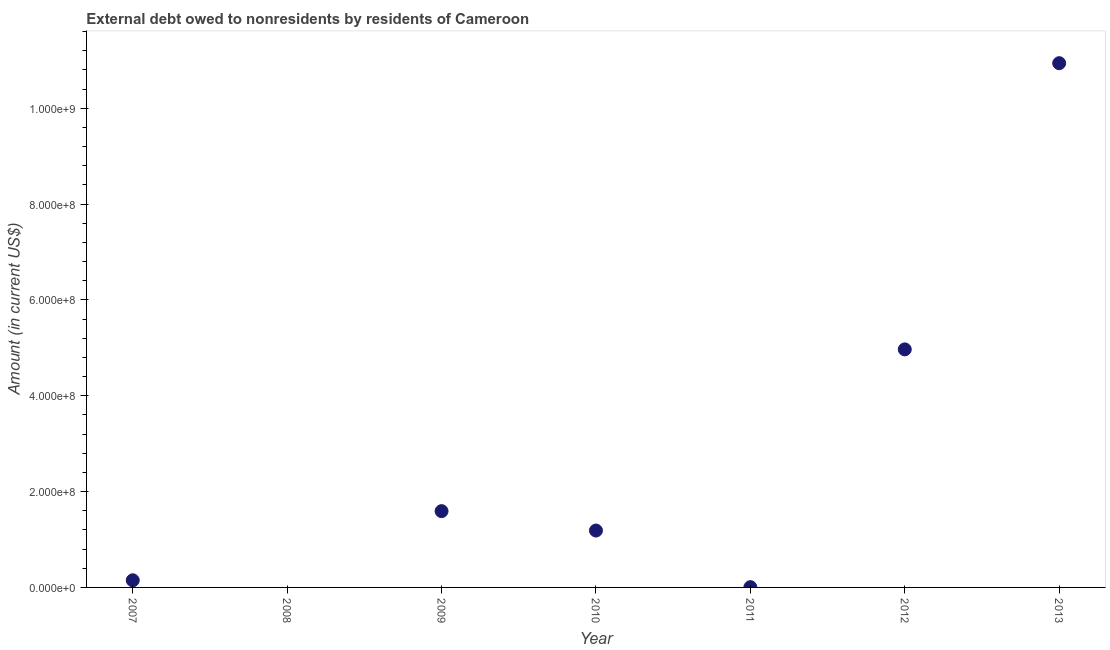What is the debt in 2009?
Offer a terse response. 1.59e+08. Across all years, what is the maximum debt?
Keep it short and to the point. 1.09e+09. Across all years, what is the minimum debt?
Keep it short and to the point. 0. In which year was the debt maximum?
Provide a succinct answer. 2013. What is the sum of the debt?
Make the answer very short. 1.88e+09. What is the difference between the debt in 2007 and 2011?
Give a very brief answer. 1.44e+07. What is the average debt per year?
Your answer should be very brief. 2.69e+08. What is the median debt?
Keep it short and to the point. 1.19e+08. What is the ratio of the debt in 2011 to that in 2013?
Provide a succinct answer. 0. What is the difference between the highest and the second highest debt?
Your response must be concise. 5.97e+08. What is the difference between the highest and the lowest debt?
Your answer should be compact. 1.09e+09. What is the difference between two consecutive major ticks on the Y-axis?
Make the answer very short. 2.00e+08. Does the graph contain grids?
Your answer should be compact. No. What is the title of the graph?
Your answer should be very brief. External debt owed to nonresidents by residents of Cameroon. What is the label or title of the Y-axis?
Ensure brevity in your answer.  Amount (in current US$). What is the Amount (in current US$) in 2007?
Offer a very short reply. 1.49e+07. What is the Amount (in current US$) in 2008?
Keep it short and to the point. 0. What is the Amount (in current US$) in 2009?
Provide a short and direct response. 1.59e+08. What is the Amount (in current US$) in 2010?
Keep it short and to the point. 1.19e+08. What is the Amount (in current US$) in 2011?
Ensure brevity in your answer.  5.33e+05. What is the Amount (in current US$) in 2012?
Ensure brevity in your answer.  4.97e+08. What is the Amount (in current US$) in 2013?
Ensure brevity in your answer.  1.09e+09. What is the difference between the Amount (in current US$) in 2007 and 2009?
Your answer should be compact. -1.44e+08. What is the difference between the Amount (in current US$) in 2007 and 2010?
Your answer should be compact. -1.04e+08. What is the difference between the Amount (in current US$) in 2007 and 2011?
Your answer should be very brief. 1.44e+07. What is the difference between the Amount (in current US$) in 2007 and 2012?
Keep it short and to the point. -4.82e+08. What is the difference between the Amount (in current US$) in 2007 and 2013?
Give a very brief answer. -1.08e+09. What is the difference between the Amount (in current US$) in 2009 and 2010?
Provide a short and direct response. 4.05e+07. What is the difference between the Amount (in current US$) in 2009 and 2011?
Keep it short and to the point. 1.59e+08. What is the difference between the Amount (in current US$) in 2009 and 2012?
Provide a succinct answer. -3.38e+08. What is the difference between the Amount (in current US$) in 2009 and 2013?
Ensure brevity in your answer.  -9.35e+08. What is the difference between the Amount (in current US$) in 2010 and 2011?
Your answer should be compact. 1.18e+08. What is the difference between the Amount (in current US$) in 2010 and 2012?
Offer a terse response. -3.78e+08. What is the difference between the Amount (in current US$) in 2010 and 2013?
Offer a terse response. -9.75e+08. What is the difference between the Amount (in current US$) in 2011 and 2012?
Provide a succinct answer. -4.96e+08. What is the difference between the Amount (in current US$) in 2011 and 2013?
Give a very brief answer. -1.09e+09. What is the difference between the Amount (in current US$) in 2012 and 2013?
Make the answer very short. -5.97e+08. What is the ratio of the Amount (in current US$) in 2007 to that in 2009?
Your answer should be compact. 0.09. What is the ratio of the Amount (in current US$) in 2007 to that in 2010?
Your answer should be compact. 0.12. What is the ratio of the Amount (in current US$) in 2007 to that in 2011?
Provide a short and direct response. 27.94. What is the ratio of the Amount (in current US$) in 2007 to that in 2013?
Provide a succinct answer. 0.01. What is the ratio of the Amount (in current US$) in 2009 to that in 2010?
Make the answer very short. 1.34. What is the ratio of the Amount (in current US$) in 2009 to that in 2011?
Keep it short and to the point. 298.7. What is the ratio of the Amount (in current US$) in 2009 to that in 2012?
Give a very brief answer. 0.32. What is the ratio of the Amount (in current US$) in 2009 to that in 2013?
Make the answer very short. 0.15. What is the ratio of the Amount (in current US$) in 2010 to that in 2011?
Your answer should be very brief. 222.72. What is the ratio of the Amount (in current US$) in 2010 to that in 2012?
Your answer should be very brief. 0.24. What is the ratio of the Amount (in current US$) in 2010 to that in 2013?
Offer a terse response. 0.11. What is the ratio of the Amount (in current US$) in 2011 to that in 2012?
Provide a short and direct response. 0. What is the ratio of the Amount (in current US$) in 2011 to that in 2013?
Provide a short and direct response. 0. What is the ratio of the Amount (in current US$) in 2012 to that in 2013?
Make the answer very short. 0.45. 